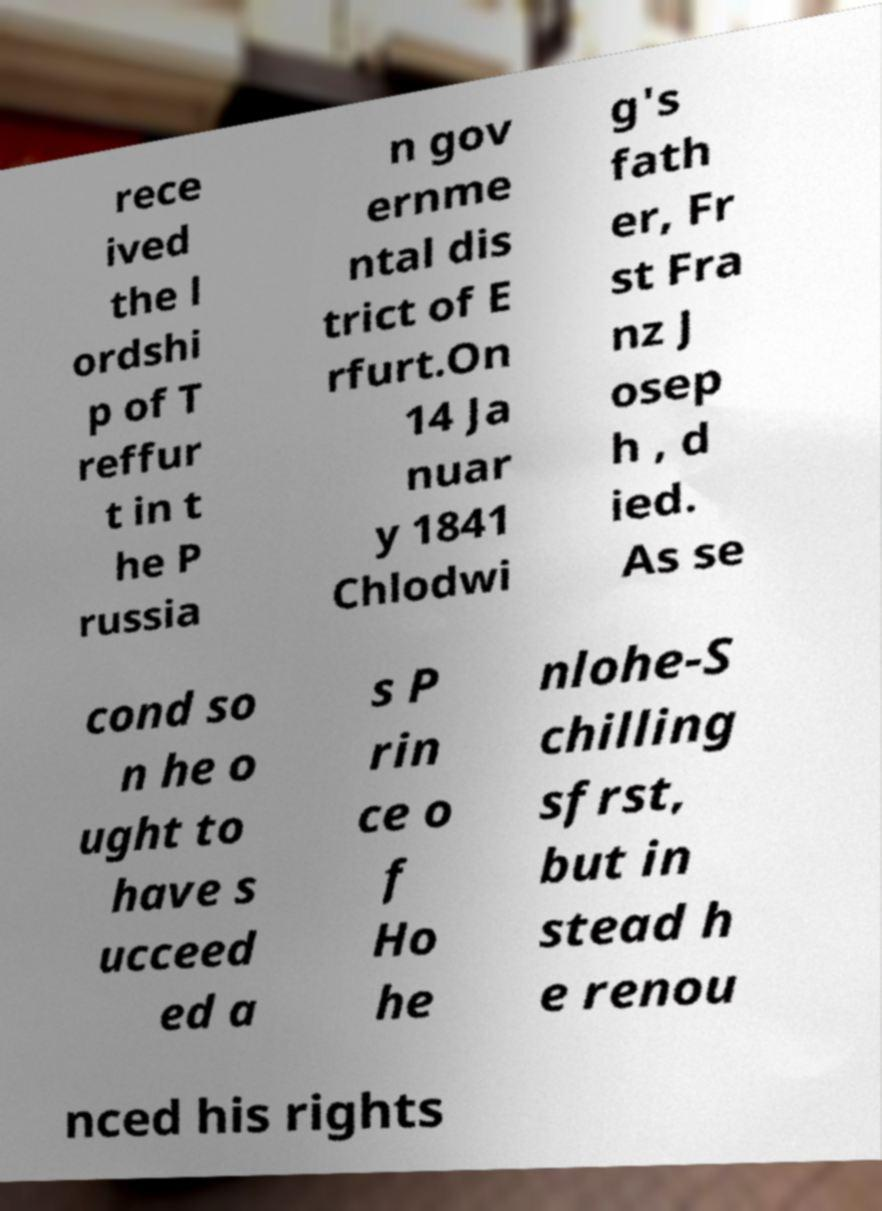Please read and relay the text visible in this image. What does it say? rece ived the l ordshi p of T reffur t in t he P russia n gov ernme ntal dis trict of E rfurt.On 14 Ja nuar y 1841 Chlodwi g's fath er, Fr st Fra nz J osep h , d ied. As se cond so n he o ught to have s ucceed ed a s P rin ce o f Ho he nlohe-S chilling sfrst, but in stead h e renou nced his rights 